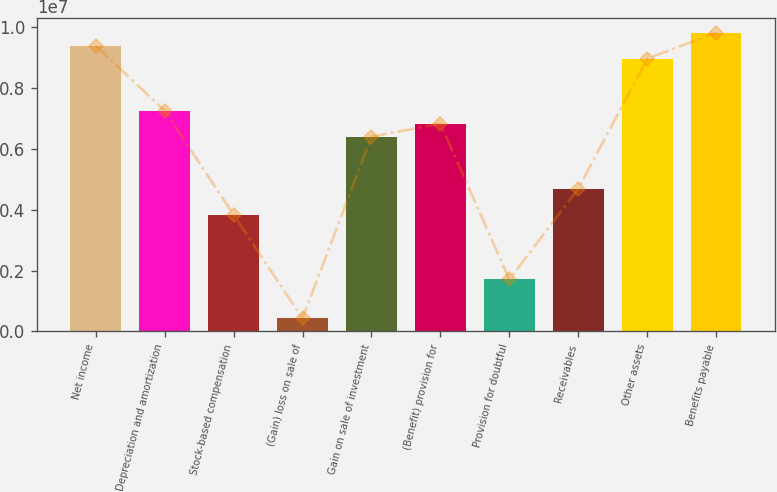Convert chart to OTSL. <chart><loc_0><loc_0><loc_500><loc_500><bar_chart><fcel>Net income<fcel>Depreciation and amortization<fcel>Stock-based compensation<fcel>(Gain) loss on sale of<fcel>Gain on sale of investment<fcel>(Benefit) provision for<fcel>Provision for doubtful<fcel>Receivables<fcel>Other assets<fcel>Benefits payable<nl><fcel>9.3915e+06<fcel>7.25722e+06<fcel>3.84236e+06<fcel>427512<fcel>6.4035e+06<fcel>6.83036e+06<fcel>1.70808e+06<fcel>4.69608e+06<fcel>8.96464e+06<fcel>9.81836e+06<nl></chart> 